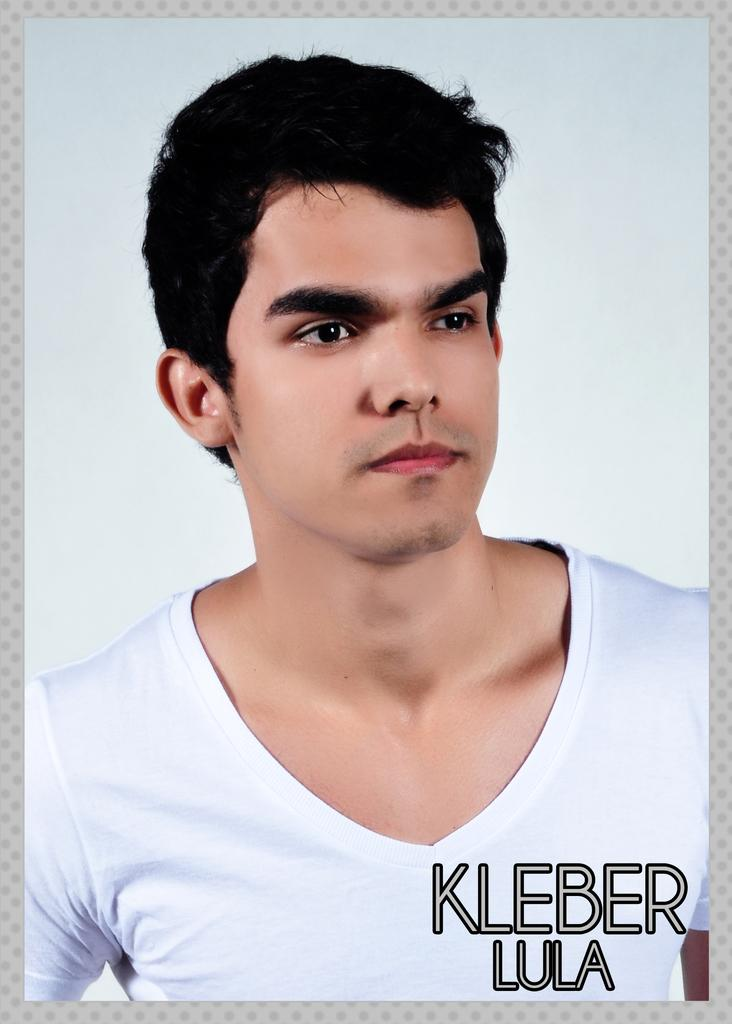What is the main subject of the image? The main subject of the image is a photo of a person. What is the person in the photo wearing? The person in the photo is wearing a t-shirt. Are there any words or designs on the t-shirt? Yes, there is text on the t-shirt. What color is the background of the photo? The background of the photo is white. How many kittens are playing in the sand in the image? There are no kittens or sand present in the image; it features a photo of a person wearing a t-shirt with text on it against a white background. 